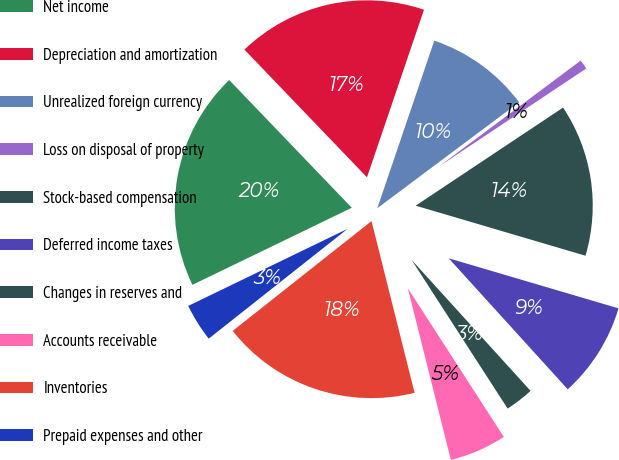<chart> <loc_0><loc_0><loc_500><loc_500><pie_chart><fcel>Net income<fcel>Depreciation and amortization<fcel>Unrealized foreign currency<fcel>Loss on disposal of property<fcel>Stock-based compensation<fcel>Deferred income taxes<fcel>Changes in reserves and<fcel>Accounts receivable<fcel>Inventories<fcel>Prepaid expenses and other<nl><fcel>20.0%<fcel>17.39%<fcel>9.57%<fcel>0.87%<fcel>13.91%<fcel>8.7%<fcel>2.61%<fcel>5.22%<fcel>18.26%<fcel>3.48%<nl></chart> 